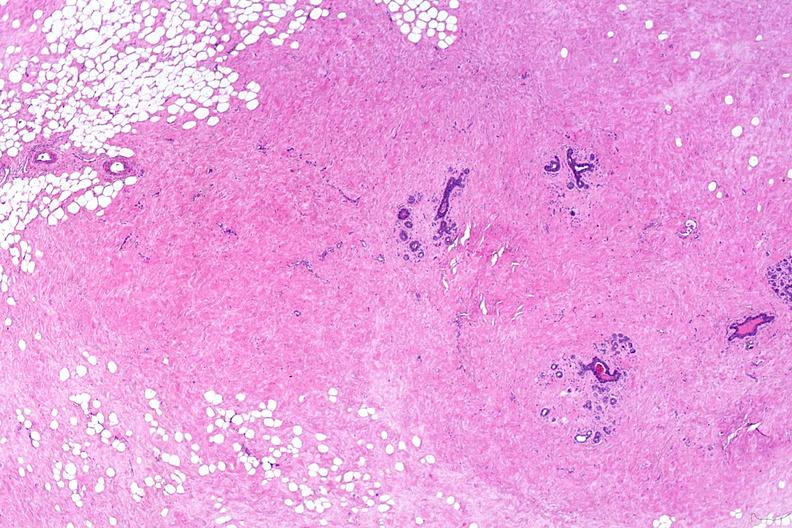does this partially fixed gross show normal breast?
Answer the question using a single word or phrase. No 